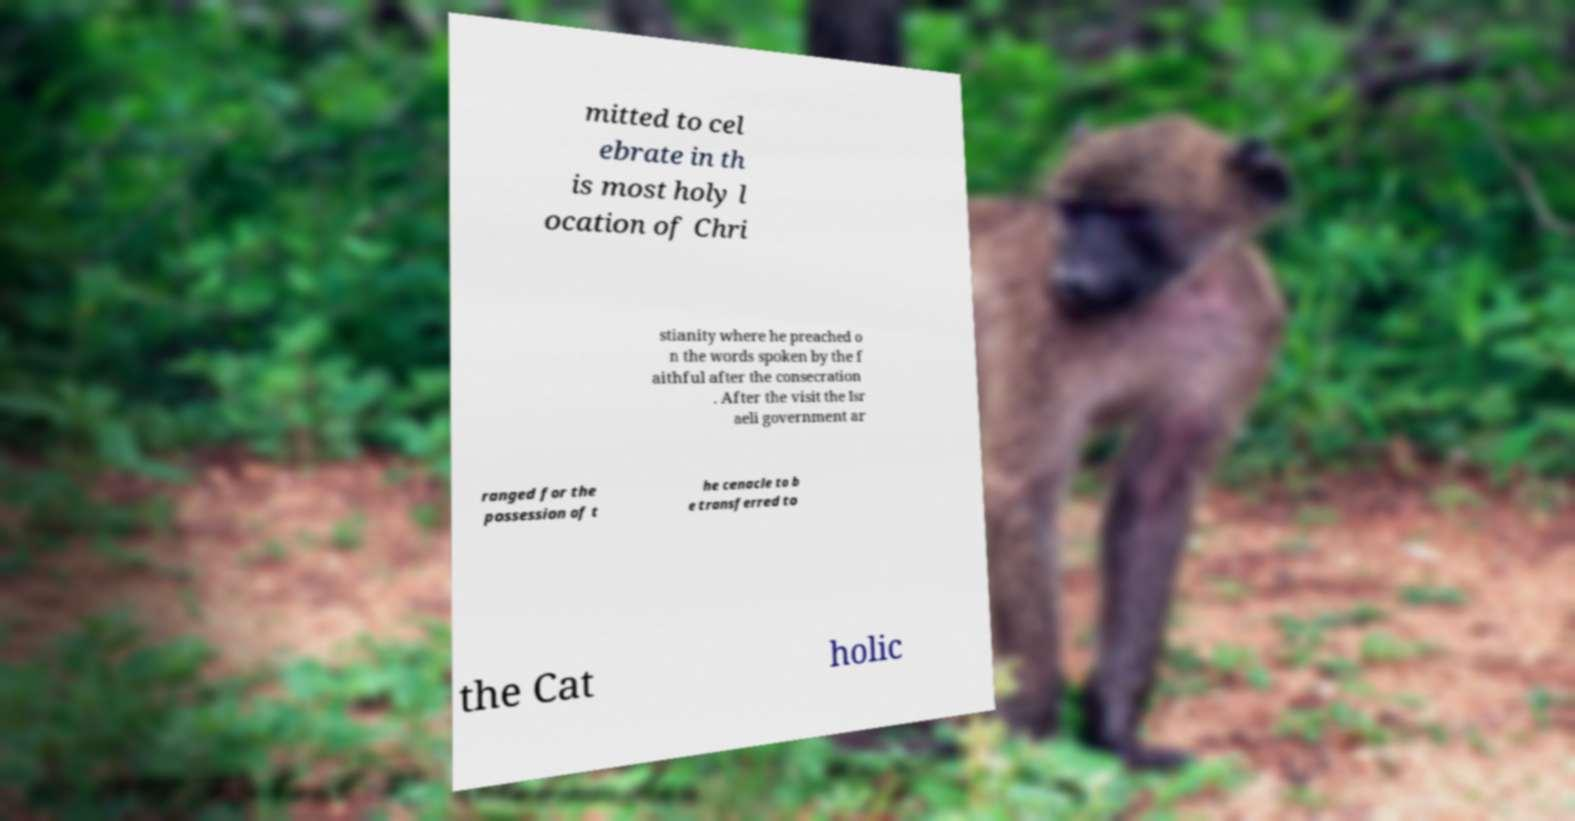For documentation purposes, I need the text within this image transcribed. Could you provide that? mitted to cel ebrate in th is most holy l ocation of Chri stianity where he preached o n the words spoken by the f aithful after the consecration . After the visit the Isr aeli government ar ranged for the possession of t he cenacle to b e transferred to the Cat holic 